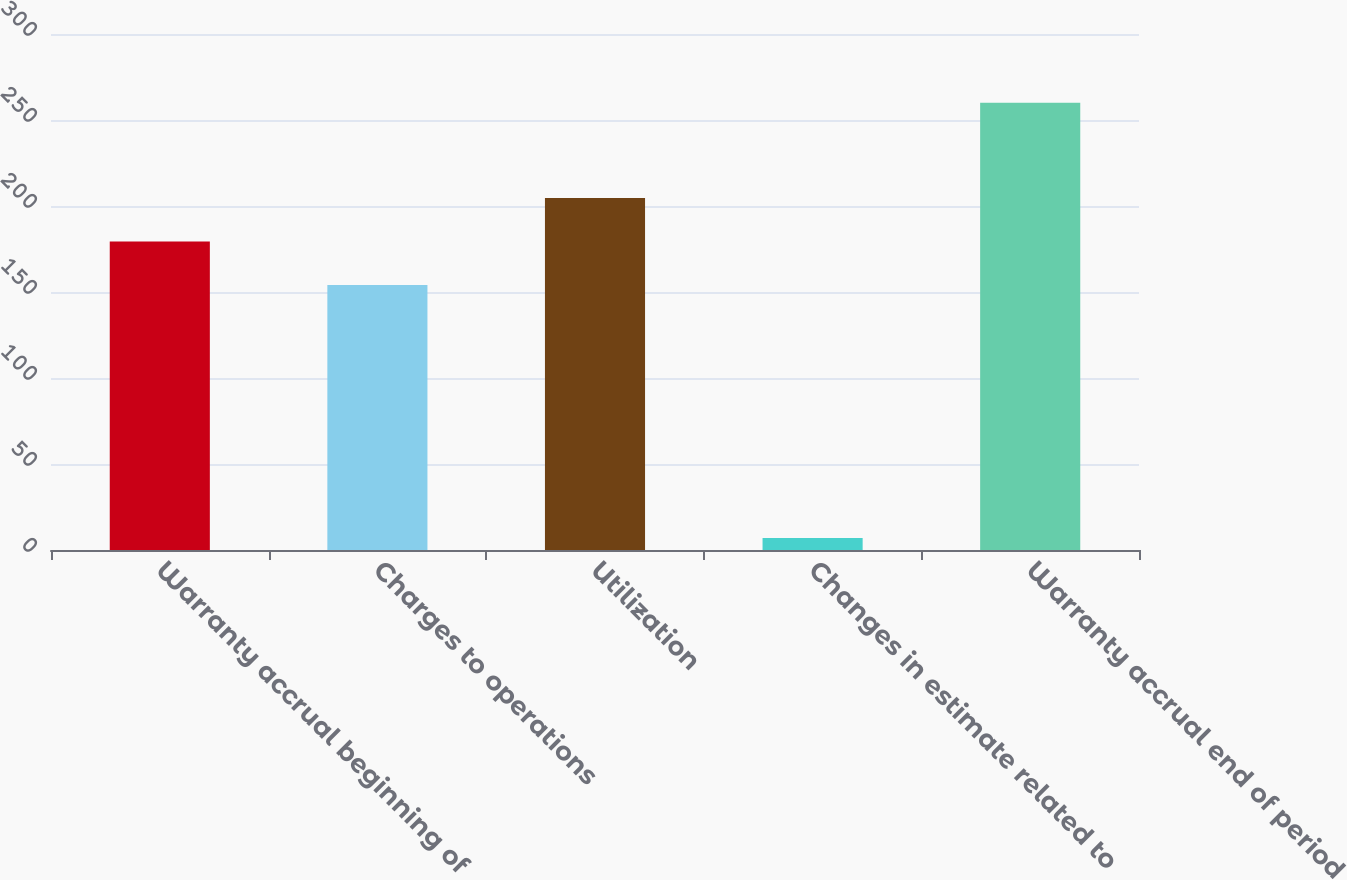<chart> <loc_0><loc_0><loc_500><loc_500><bar_chart><fcel>Warranty accrual beginning of<fcel>Charges to operations<fcel>Utilization<fcel>Changes in estimate related to<fcel>Warranty accrual end of period<nl><fcel>179.3<fcel>154<fcel>204.6<fcel>7<fcel>260<nl></chart> 